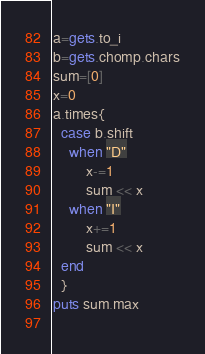Convert code to text. <code><loc_0><loc_0><loc_500><loc_500><_Ruby_>a=gets.to_i
b=gets.chomp.chars
sum=[0]
x=0
a.times{
  case b.shift
	when "D"
    	x-=1
    	sum << x
  	when "I"
    	x+=1
    	sum << x
  end
  }
puts sum.max
  </code> 